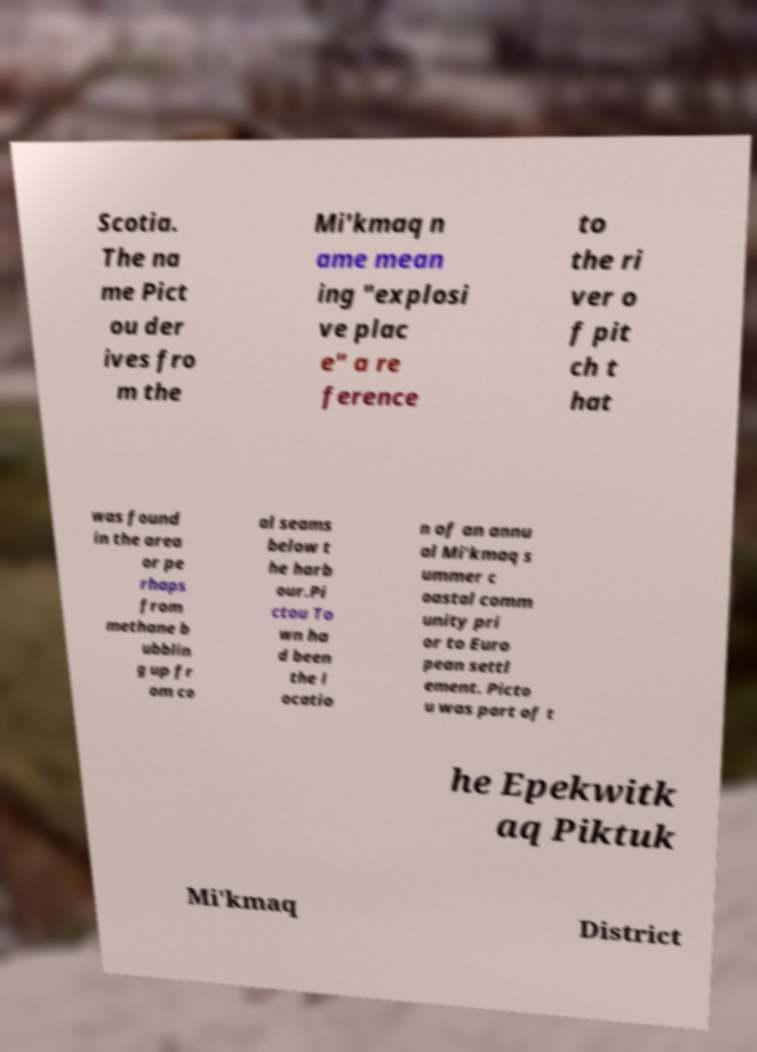Could you assist in decoding the text presented in this image and type it out clearly? Scotia. The na me Pict ou der ives fro m the Mi'kmaq n ame mean ing "explosi ve plac e" a re ference to the ri ver o f pit ch t hat was found in the area or pe rhaps from methane b ubblin g up fr om co al seams below t he harb our.Pi ctou To wn ha d been the l ocatio n of an annu al Mi'kmaq s ummer c oastal comm unity pri or to Euro pean settl ement. Picto u was part of t he Epekwitk aq Piktuk Mi'kmaq District 